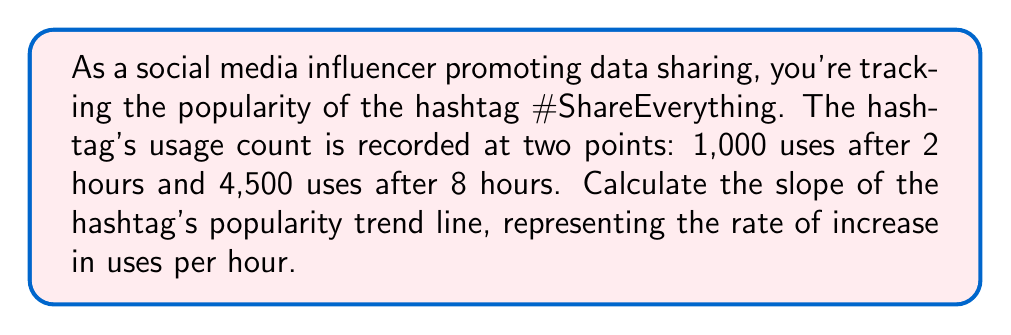Provide a solution to this math problem. To calculate the slope of the trending hashtag's popularity over time, we'll use the slope formula:

$$ m = \frac{y_2 - y_1}{x_2 - x_1} $$

Where:
- $m$ is the slope
- $(x_1, y_1)$ is the first point (time in hours, number of uses)
- $(x_2, y_2)$ is the second point (time in hours, number of uses)

Given:
- Point 1: $(2, 1000)$
- Point 2: $(8, 4500)$

Let's substitute these values into the slope formula:

$$ m = \frac{4500 - 1000}{8 - 2} = \frac{3500}{6} $$

Simplifying:

$$ m = \frac{3500}{6} = \frac{1750}{3} \approx 583.33 $$

This slope represents the rate of increase in hashtag uses per hour.
Answer: The slope of the hashtag's popularity trend line is $\frac{1750}{3}$ uses per hour, or approximately 583.33 uses per hour. 